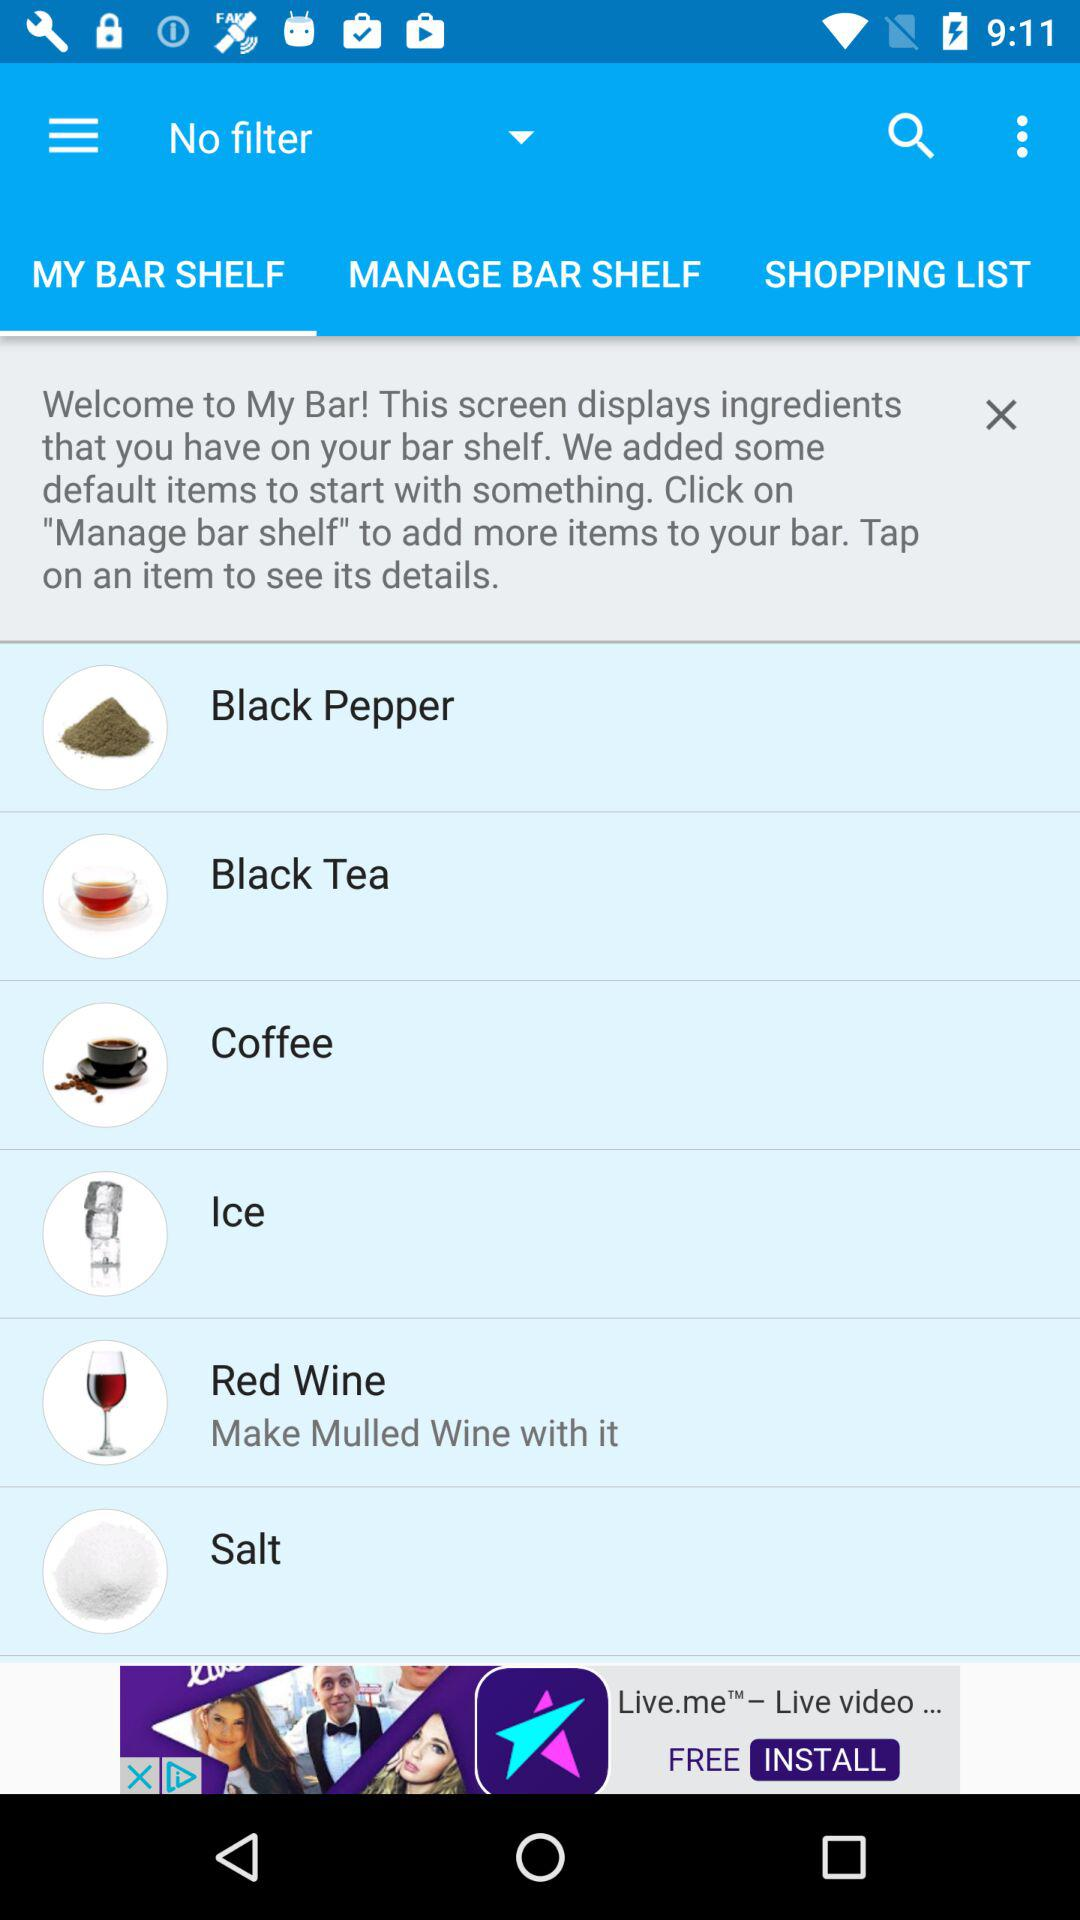Which tab is selected? The selected tab is "MY BAR SHELF". 